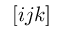Convert formula to latex. <formula><loc_0><loc_0><loc_500><loc_500>[ i j k ]</formula> 